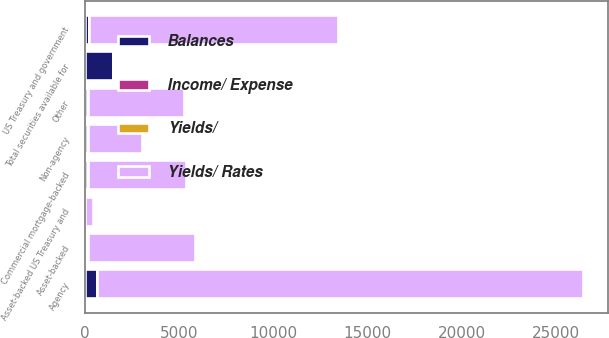Convert chart to OTSL. <chart><loc_0><loc_0><loc_500><loc_500><stacked_bar_chart><ecel><fcel>Agency<fcel>Non-agency<fcel>Commercial mortgage-backed<fcel>Asset-backed<fcel>US Treasury and government<fcel>Other<fcel>Total securities available for<fcel>Asset-backed US Treasury and<nl><fcel>Yields/ Rates<fcel>25766<fcel>2851<fcel>5193<fcel>5681<fcel>13178<fcel>5083<fcel>5.37<fcel>405<nl><fcel>Balances<fcel>662<fcel>153<fcel>156<fcel>147<fcel>235<fcel>158<fcel>1511<fcel>10<nl><fcel>Income/ Expense<fcel>2.57<fcel>5.37<fcel>3<fcel>2.59<fcel>1.78<fcel>3.11<fcel>2.62<fcel>2.47<nl><fcel>Yields/<fcel>2.43<fcel>4.84<fcel>2.62<fcel>2.3<fcel>1.46<fcel>3<fcel>2.46<fcel>2.07<nl></chart> 